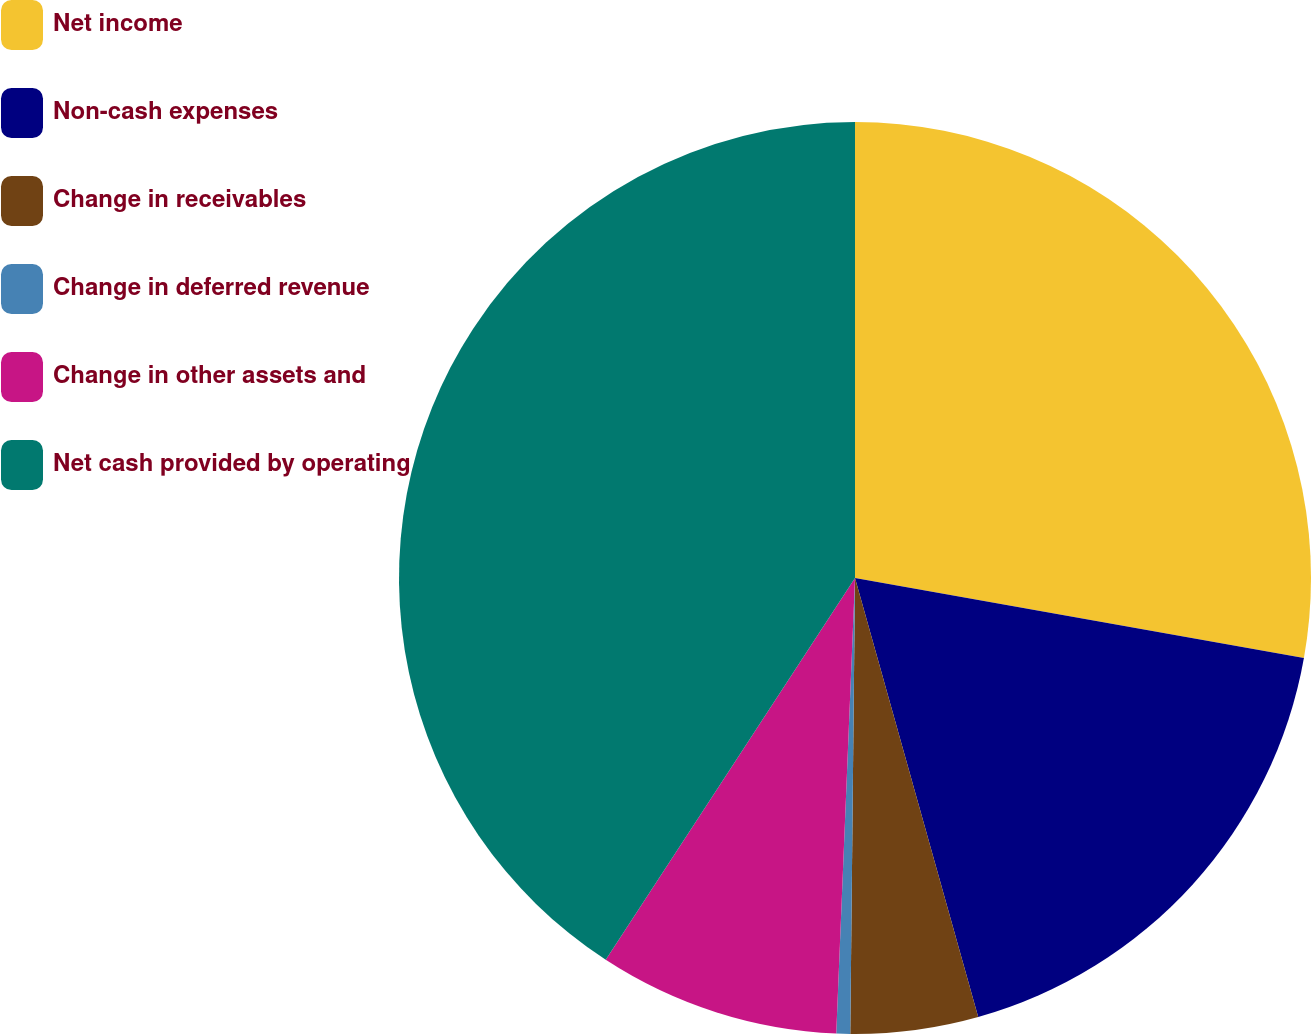Convert chart. <chart><loc_0><loc_0><loc_500><loc_500><pie_chart><fcel>Net income<fcel>Non-cash expenses<fcel>Change in receivables<fcel>Change in deferred revenue<fcel>Change in other assets and<fcel>Net cash provided by operating<nl><fcel>27.81%<fcel>17.84%<fcel>4.52%<fcel>0.49%<fcel>8.55%<fcel>40.8%<nl></chart> 